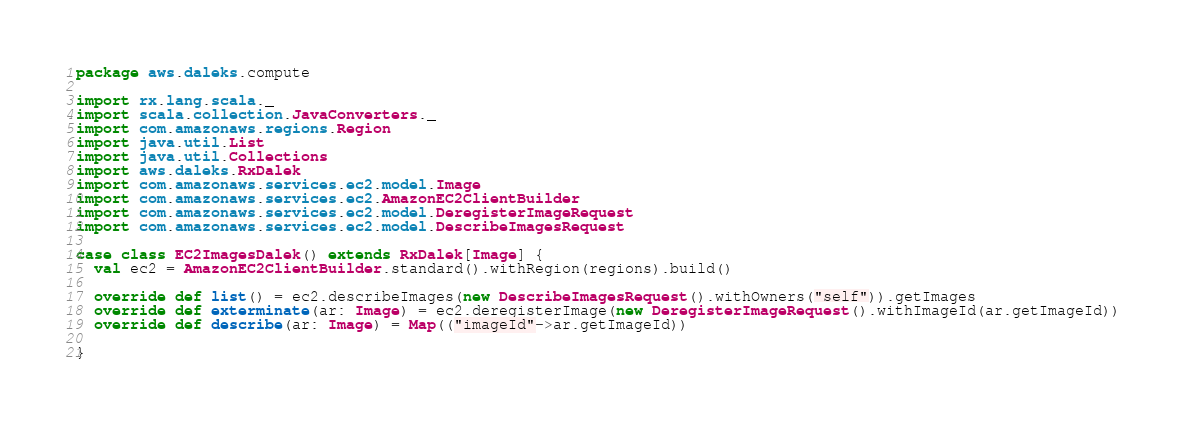<code> <loc_0><loc_0><loc_500><loc_500><_Scala_>package aws.daleks.compute

import rx.lang.scala._
import scala.collection.JavaConverters._
import com.amazonaws.regions.Region
import java.util.List
import java.util.Collections
import aws.daleks.RxDalek
import com.amazonaws.services.ec2.model.Image
import com.amazonaws.services.ec2.AmazonEC2ClientBuilder
import com.amazonaws.services.ec2.model.DeregisterImageRequest
import com.amazonaws.services.ec2.model.DescribeImagesRequest

case class EC2ImagesDalek() extends RxDalek[Image] {
  val ec2 = AmazonEC2ClientBuilder.standard().withRegion(regions).build()
  
  override def list() = ec2.describeImages(new DescribeImagesRequest().withOwners("self")).getImages
  override def exterminate(ar: Image) = ec2.deregisterImage(new DeregisterImageRequest().withImageId(ar.getImageId))
  override def describe(ar: Image) = Map(("imageId"->ar.getImageId))

}


</code> 